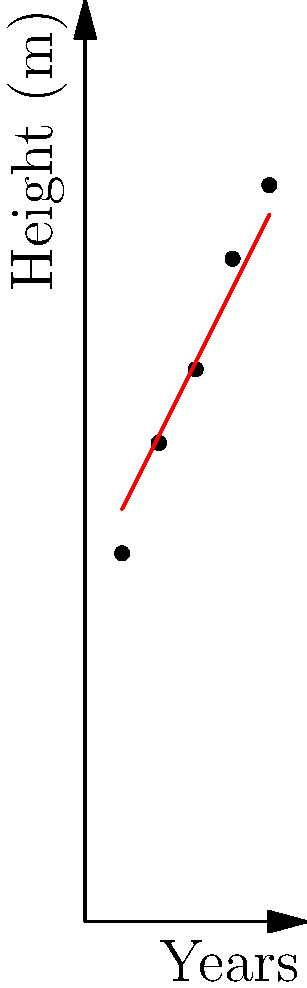As a field assistant collecting data on tree species diversity, you have measured the height of a particular tree species over 5 years. The data points (year, height in meters) are: (1, 10), (2, 13), (3, 15), (4, 18), and (5, 20). Using the least squares method, determine the equation of the line of best fit for this data set. Round coefficients to two decimal places. To find the line of best fit using the least squares method, we'll follow these steps:

1) First, we need to calculate the following sums:
   $\sum x = 1 + 2 + 3 + 4 + 5 = 15$
   $\sum y = 10 + 13 + 15 + 18 + 20 = 76$
   $\sum x^2 = 1^2 + 2^2 + 3^2 + 4^2 + 5^2 = 55$
   $\sum xy = 1(10) + 2(13) + 3(15) + 4(18) + 5(20) = 250$
   $n = 5$ (number of data points)

2) Now we can use these formulas:
   $m = \frac{n\sum xy - \sum x \sum y}{n\sum x^2 - (\sum x)^2}$
   $b = \frac{\sum y - m\sum x}{n}$

3) Let's calculate $m$:
   $m = \frac{5(250) - 15(76)}{5(55) - 15^2}$
   $m = \frac{1250 - 1140}{275 - 225}$
   $m = \frac{110}{50} = 2.20$

4) Now let's calculate $b$:
   $b = \frac{76 - 2.20(15)}{5}$
   $b = \frac{76 - 33}{5}$
   $b = \frac{43}{5} = 8.60$

5) Therefore, the equation of the line of best fit is:
   $y = 2.20x + 8.60$

Where $y$ represents the tree height in meters and $x$ represents the year (with year 1 being the first year of measurement).
Answer: $y = 2.20x + 8.60$ 